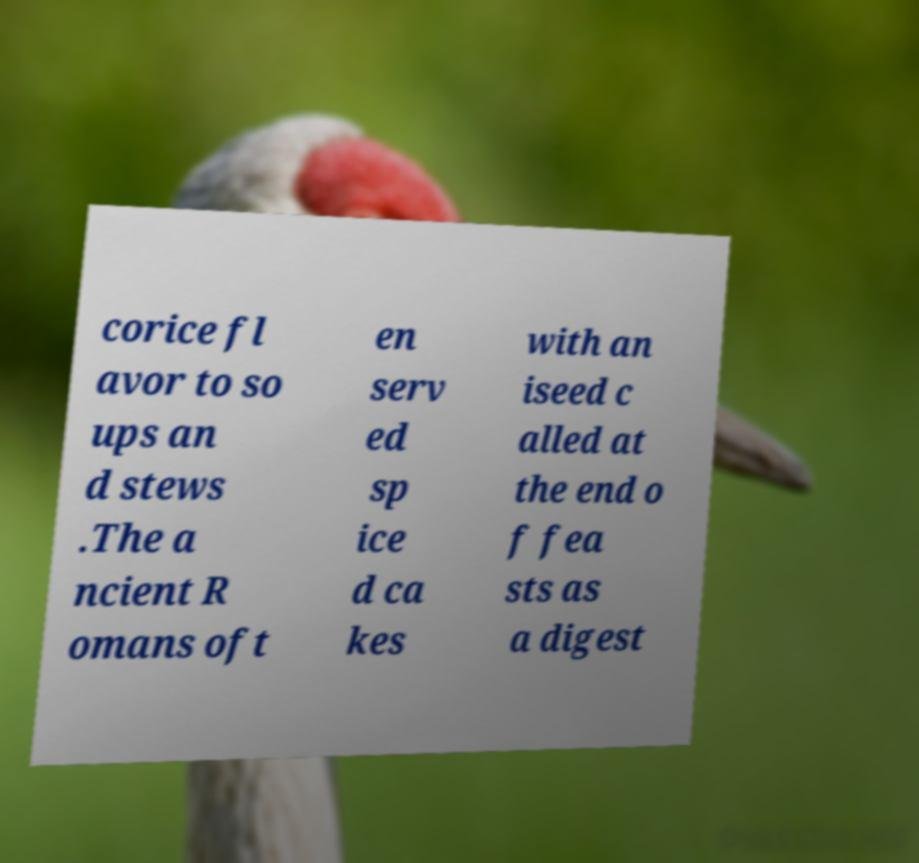Could you assist in decoding the text presented in this image and type it out clearly? corice fl avor to so ups an d stews .The a ncient R omans oft en serv ed sp ice d ca kes with an iseed c alled at the end o f fea sts as a digest 